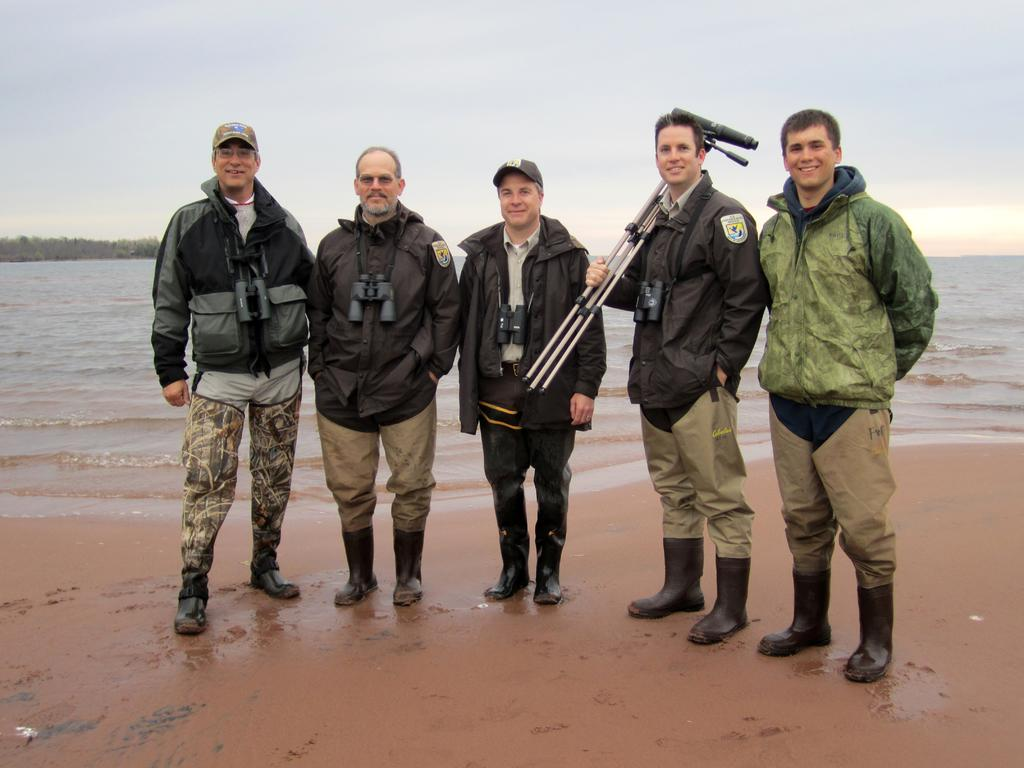What can be seen in the image regarding the people present? There are men standing in the image. What type of footwear are the men wearing? The men are wearing boots. What type of clothing are the men wearing? The men are wearing clothes. What natural element is visible in the image? There is water visible in the image. What part of the environment can be seen in the image? The sky is visible in the image. What type of magic is being performed by the men in the image? There is no indication of magic or any magical activity in the image. What emotion can be seen on the faces of the men in the image? The provided facts do not mention the emotions or expressions of the men, so it cannot be determined from the image. 